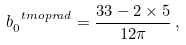<formula> <loc_0><loc_0><loc_500><loc_500>b _ { 0 } ^ { \ t m o p { r a d } } = \frac { 3 3 - 2 \times 5 } { 1 2 \pi } \, ,</formula> 